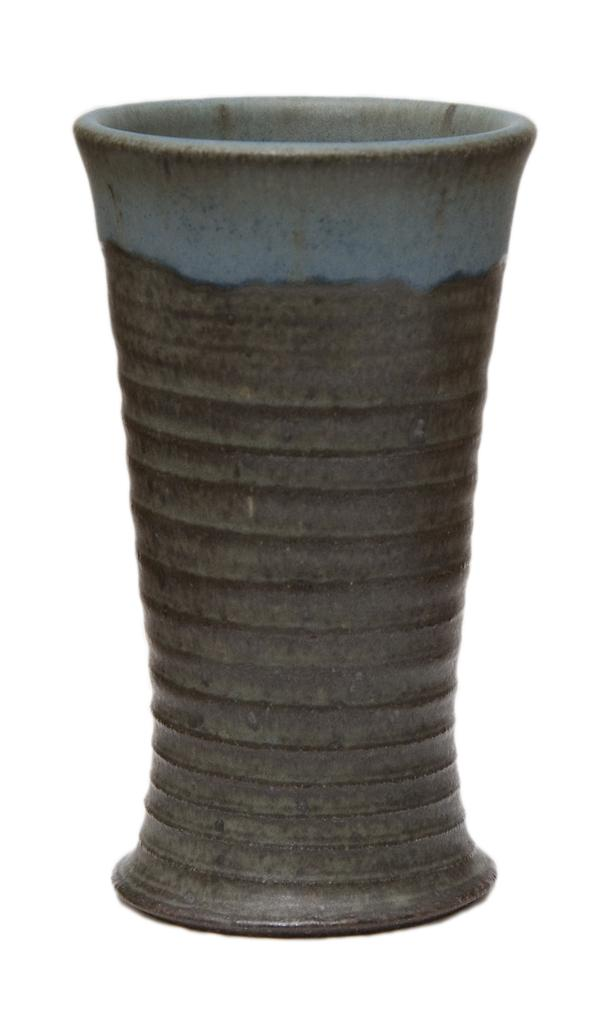What object is the main focus of the image? There is a clay pot in the image. What color is the background of the image? The background of the image is white. Where is the scarecrow located in the image? There is no scarecrow present in the image. How many people are in the crowd in the image? There is no crowd present in the image. 